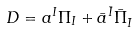<formula> <loc_0><loc_0><loc_500><loc_500>D = a ^ { I } \Pi _ { I } + \bar { a } ^ { \bar { I } } \bar { \Pi } _ { \bar { I } }</formula> 